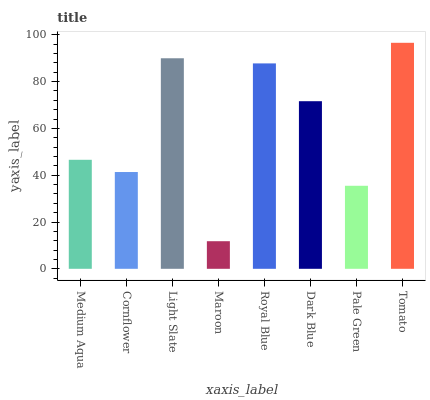Is Maroon the minimum?
Answer yes or no. Yes. Is Tomato the maximum?
Answer yes or no. Yes. Is Cornflower the minimum?
Answer yes or no. No. Is Cornflower the maximum?
Answer yes or no. No. Is Medium Aqua greater than Cornflower?
Answer yes or no. Yes. Is Cornflower less than Medium Aqua?
Answer yes or no. Yes. Is Cornflower greater than Medium Aqua?
Answer yes or no. No. Is Medium Aqua less than Cornflower?
Answer yes or no. No. Is Dark Blue the high median?
Answer yes or no. Yes. Is Medium Aqua the low median?
Answer yes or no. Yes. Is Pale Green the high median?
Answer yes or no. No. Is Pale Green the low median?
Answer yes or no. No. 